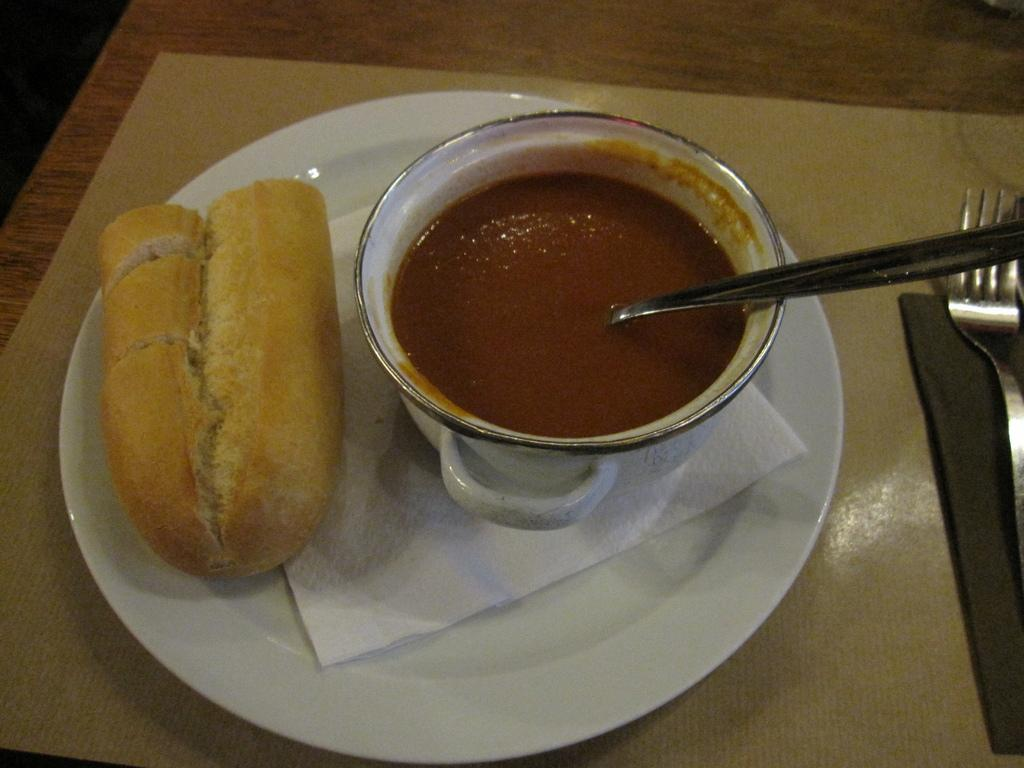What type of table is in the image? There is a wooden table in the image. What is placed on the wooden table? There is a dining mat on the table. What is on the dining mat? There is a plate on the table, and it contains tissue paper, bread, and a bowl of soup. What utensils are present on the table? There is a fork on the table, and there is also a serving spoon in the image. What type of committee is meeting on the ship in the image? There is no committee or ship present in the image; it features a wooden table with a dining mat, plate, and utensils. 